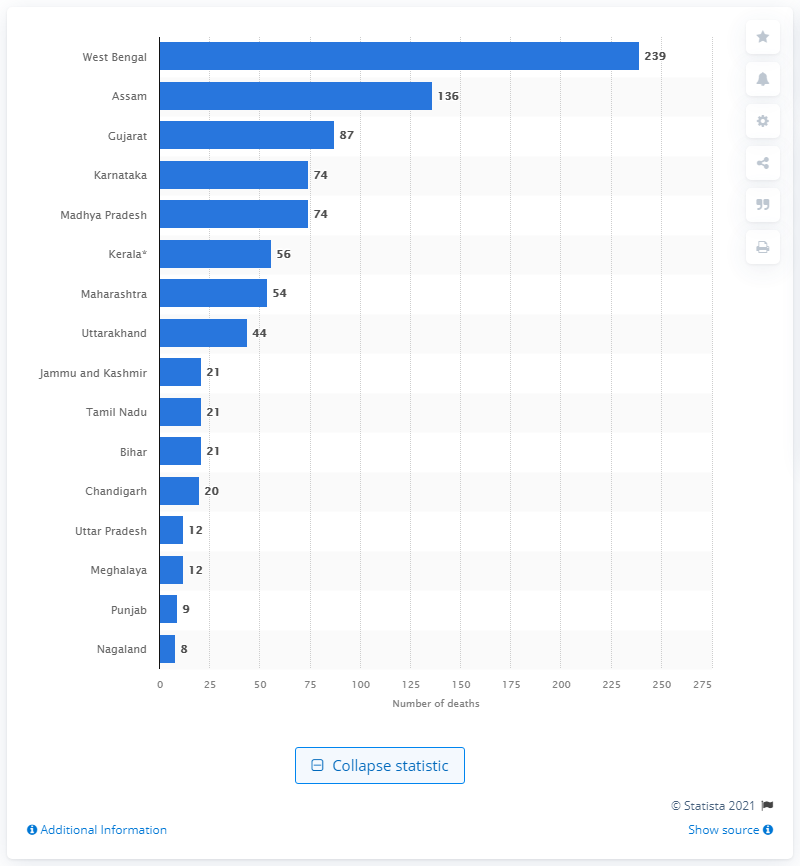Point out several critical features in this image. During the monsoon season in West Bengal, a total of 239 people lost their lives. 